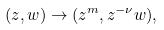Convert formula to latex. <formula><loc_0><loc_0><loc_500><loc_500>( z , w ) \rightarrow ( z ^ { m } , z ^ { - \nu } w ) ,</formula> 